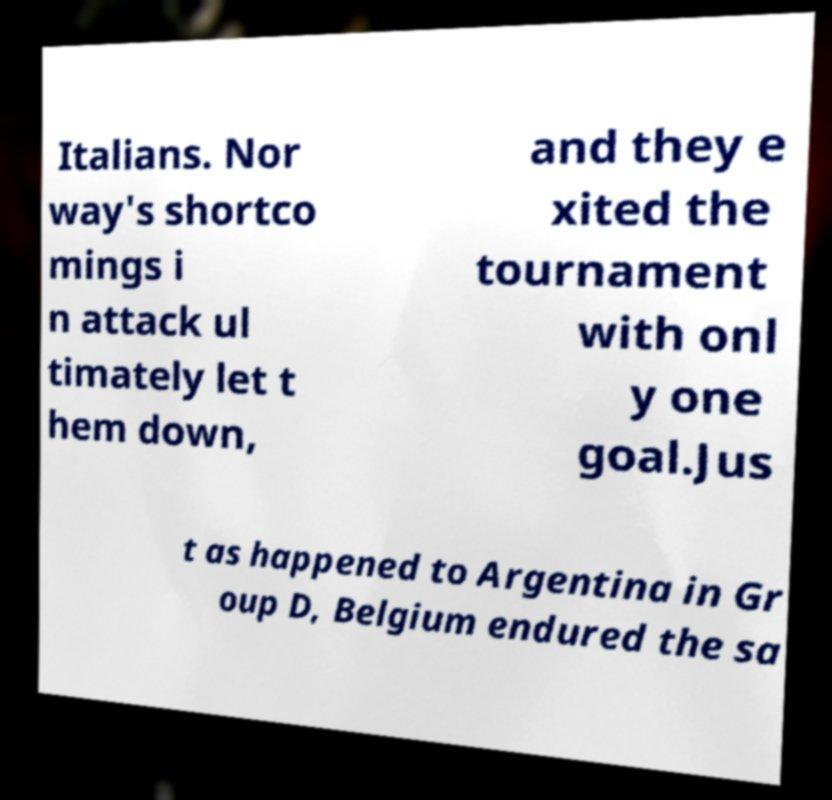For documentation purposes, I need the text within this image transcribed. Could you provide that? Italians. Nor way's shortco mings i n attack ul timately let t hem down, and they e xited the tournament with onl y one goal.Jus t as happened to Argentina in Gr oup D, Belgium endured the sa 